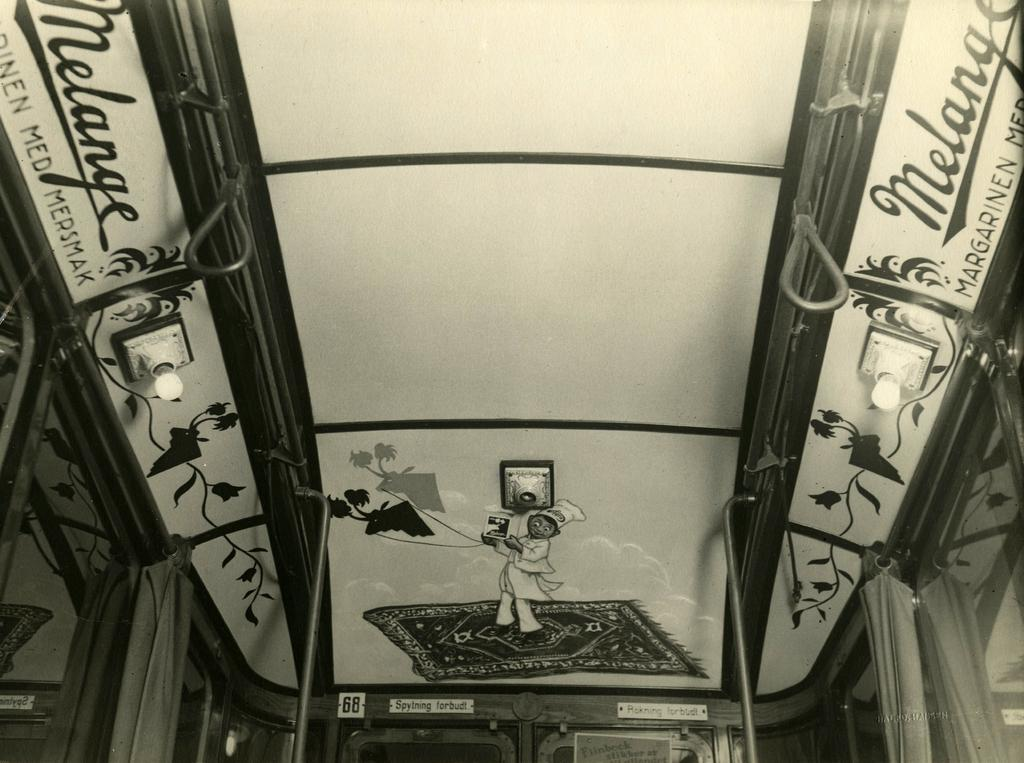What is depicted in the paintings in the image? The paintings depict a person, plants, and texts. What type of lighting is present in the image? There are lights attached to the roof in the image. What type of windows are present in the image? There are glass windows in the image. What type of window treatment is present in the image? There are curtains associated with the windows. What type of sand can be seen on the floor in the image? There is no sand present on the floor in the image. What territory is being claimed by the person depicted in the painting? The painting does not depict a person claiming any territory. 